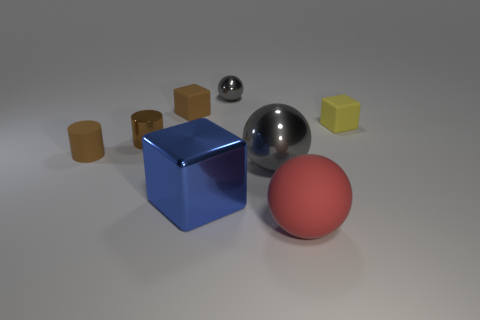There is a big shiny thing that is the same color as the tiny metallic ball; what is its shape?
Ensure brevity in your answer.  Sphere. Is the blue metallic thing the same shape as the tiny yellow thing?
Keep it short and to the point. Yes. Are there an equal number of large metallic spheres that are behind the small brown metal object and large purple metallic cubes?
Your answer should be very brief. Yes. What number of other things are made of the same material as the big gray sphere?
Keep it short and to the point. 3. There is a ball that is in front of the blue metal block; is its size the same as the gray metal ball in front of the brown metallic cylinder?
Your answer should be very brief. Yes. What number of things are either gray objects that are in front of the small gray shiny object or objects that are behind the large cube?
Your response must be concise. 6. Is the color of the small rubber cylinder behind the large shiny ball the same as the tiny matte block left of the big matte sphere?
Offer a terse response. Yes. How many metal objects are either big balls or large red objects?
Your answer should be very brief. 1. There is a brown rubber thing in front of the tiny matte cube that is to the right of the metallic cube; what is its shape?
Keep it short and to the point. Cylinder. Do the big cube to the left of the tiny gray sphere and the tiny brown cylinder that is behind the tiny matte cylinder have the same material?
Your answer should be compact. Yes. 